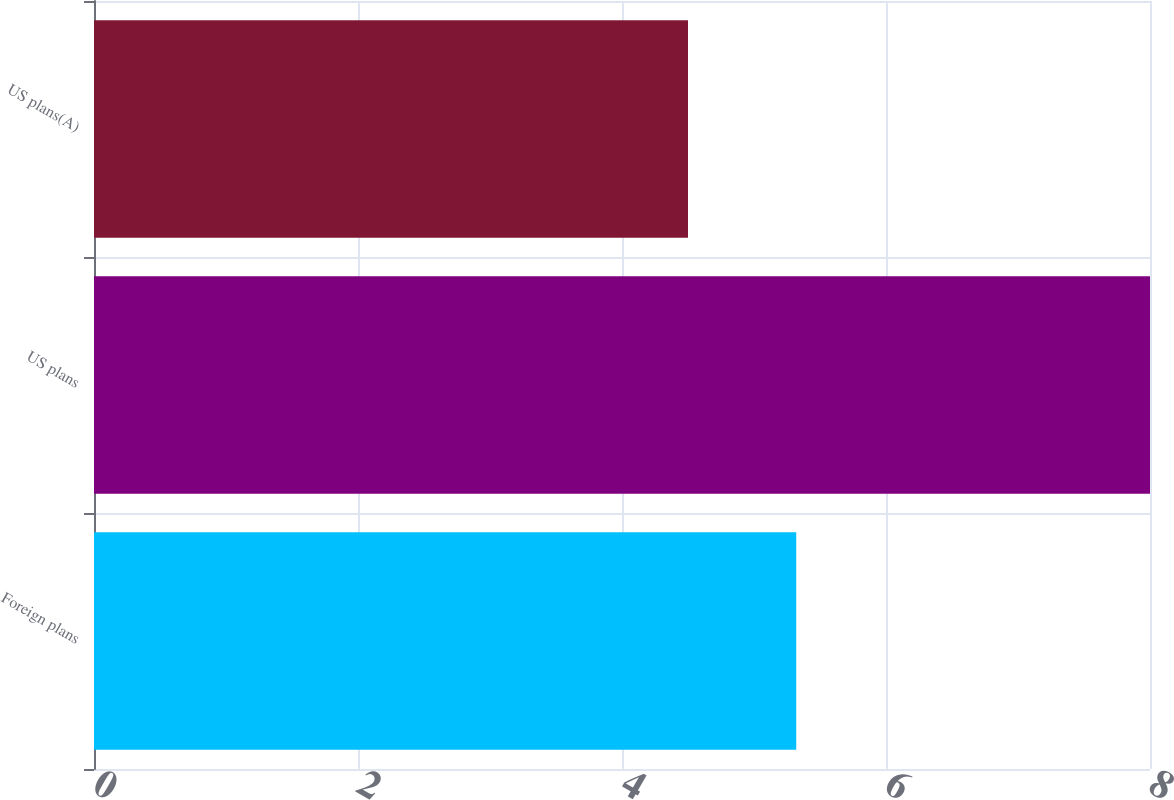<chart> <loc_0><loc_0><loc_500><loc_500><bar_chart><fcel>Foreign plans<fcel>US plans<fcel>US plans(A)<nl><fcel>5.32<fcel>8<fcel>4.5<nl></chart> 